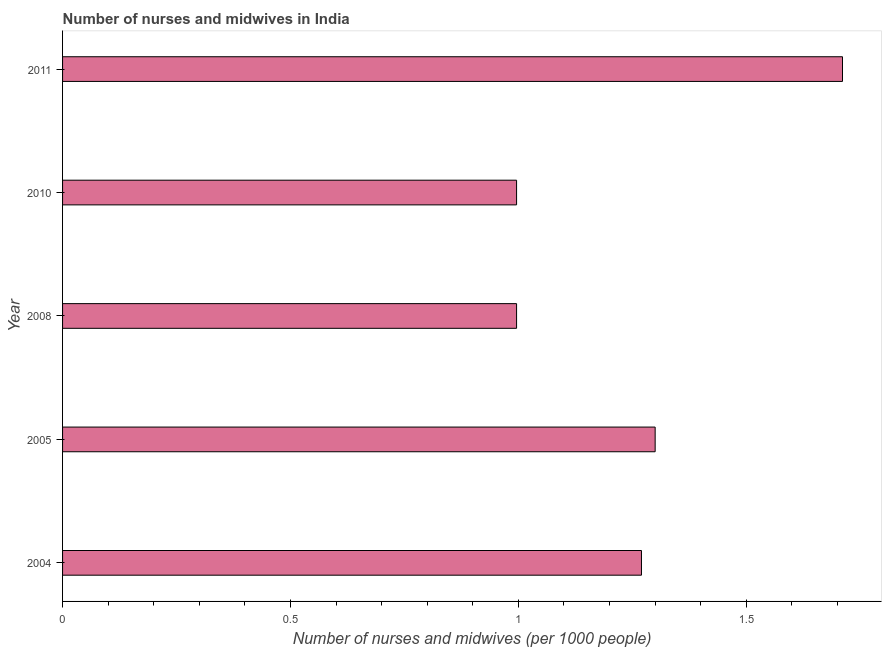Does the graph contain any zero values?
Provide a succinct answer. No. What is the title of the graph?
Provide a succinct answer. Number of nurses and midwives in India. What is the label or title of the X-axis?
Your answer should be compact. Number of nurses and midwives (per 1000 people). What is the number of nurses and midwives in 2008?
Make the answer very short. 1. Across all years, what is the maximum number of nurses and midwives?
Your response must be concise. 1.71. Across all years, what is the minimum number of nurses and midwives?
Provide a succinct answer. 1. In which year was the number of nurses and midwives maximum?
Make the answer very short. 2011. What is the sum of the number of nurses and midwives?
Give a very brief answer. 6.27. What is the difference between the number of nurses and midwives in 2008 and 2010?
Provide a succinct answer. 0. What is the average number of nurses and midwives per year?
Offer a terse response. 1.25. What is the median number of nurses and midwives?
Ensure brevity in your answer.  1.27. What is the ratio of the number of nurses and midwives in 2005 to that in 2011?
Your response must be concise. 0.76. Is the number of nurses and midwives in 2005 less than that in 2008?
Your answer should be compact. No. What is the difference between the highest and the second highest number of nurses and midwives?
Your answer should be compact. 0.41. Is the sum of the number of nurses and midwives in 2008 and 2010 greater than the maximum number of nurses and midwives across all years?
Ensure brevity in your answer.  Yes. What is the difference between the highest and the lowest number of nurses and midwives?
Ensure brevity in your answer.  0.72. In how many years, is the number of nurses and midwives greater than the average number of nurses and midwives taken over all years?
Your answer should be compact. 3. How many bars are there?
Your answer should be very brief. 5. Are the values on the major ticks of X-axis written in scientific E-notation?
Make the answer very short. No. What is the Number of nurses and midwives (per 1000 people) in 2004?
Offer a terse response. 1.27. What is the Number of nurses and midwives (per 1000 people) in 2005?
Ensure brevity in your answer.  1.3. What is the Number of nurses and midwives (per 1000 people) of 2008?
Offer a very short reply. 1. What is the Number of nurses and midwives (per 1000 people) in 2010?
Provide a succinct answer. 1. What is the Number of nurses and midwives (per 1000 people) in 2011?
Your answer should be compact. 1.71. What is the difference between the Number of nurses and midwives (per 1000 people) in 2004 and 2005?
Keep it short and to the point. -0.03. What is the difference between the Number of nurses and midwives (per 1000 people) in 2004 and 2008?
Provide a short and direct response. 0.27. What is the difference between the Number of nurses and midwives (per 1000 people) in 2004 and 2010?
Provide a short and direct response. 0.27. What is the difference between the Number of nurses and midwives (per 1000 people) in 2004 and 2011?
Make the answer very short. -0.44. What is the difference between the Number of nurses and midwives (per 1000 people) in 2005 and 2008?
Your answer should be very brief. 0.3. What is the difference between the Number of nurses and midwives (per 1000 people) in 2005 and 2010?
Provide a short and direct response. 0.3. What is the difference between the Number of nurses and midwives (per 1000 people) in 2005 and 2011?
Provide a short and direct response. -0.41. What is the difference between the Number of nurses and midwives (per 1000 people) in 2008 and 2010?
Provide a short and direct response. 0. What is the difference between the Number of nurses and midwives (per 1000 people) in 2008 and 2011?
Make the answer very short. -0.71. What is the difference between the Number of nurses and midwives (per 1000 people) in 2010 and 2011?
Keep it short and to the point. -0.71. What is the ratio of the Number of nurses and midwives (per 1000 people) in 2004 to that in 2005?
Ensure brevity in your answer.  0.98. What is the ratio of the Number of nurses and midwives (per 1000 people) in 2004 to that in 2008?
Make the answer very short. 1.27. What is the ratio of the Number of nurses and midwives (per 1000 people) in 2004 to that in 2010?
Your answer should be very brief. 1.27. What is the ratio of the Number of nurses and midwives (per 1000 people) in 2004 to that in 2011?
Keep it short and to the point. 0.74. What is the ratio of the Number of nurses and midwives (per 1000 people) in 2005 to that in 2008?
Your answer should be compact. 1.3. What is the ratio of the Number of nurses and midwives (per 1000 people) in 2005 to that in 2010?
Keep it short and to the point. 1.3. What is the ratio of the Number of nurses and midwives (per 1000 people) in 2005 to that in 2011?
Make the answer very short. 0.76. What is the ratio of the Number of nurses and midwives (per 1000 people) in 2008 to that in 2011?
Your answer should be compact. 0.58. What is the ratio of the Number of nurses and midwives (per 1000 people) in 2010 to that in 2011?
Your answer should be compact. 0.58. 